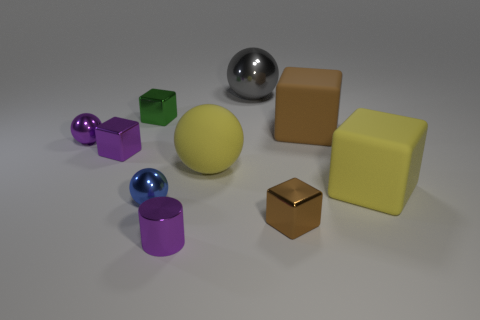Subtract 1 blocks. How many blocks are left? 4 Subtract all yellow spheres. How many spheres are left? 3 Subtract all yellow rubber balls. How many balls are left? 3 Subtract all green cubes. Subtract all yellow spheres. How many cubes are left? 4 Subtract all cylinders. How many objects are left? 9 Add 2 small purple rubber cubes. How many small purple rubber cubes exist? 2 Subtract 1 yellow balls. How many objects are left? 9 Subtract all large yellow matte things. Subtract all small cylinders. How many objects are left? 7 Add 7 tiny purple shiny blocks. How many tiny purple shiny blocks are left? 8 